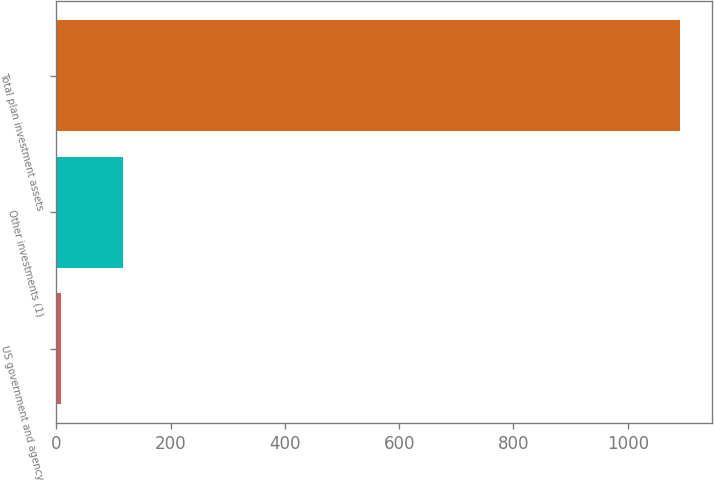<chart> <loc_0><loc_0><loc_500><loc_500><bar_chart><fcel>US government and agency<fcel>Other investments (1)<fcel>Total plan investment assets<nl><fcel>9<fcel>117.3<fcel>1092<nl></chart> 